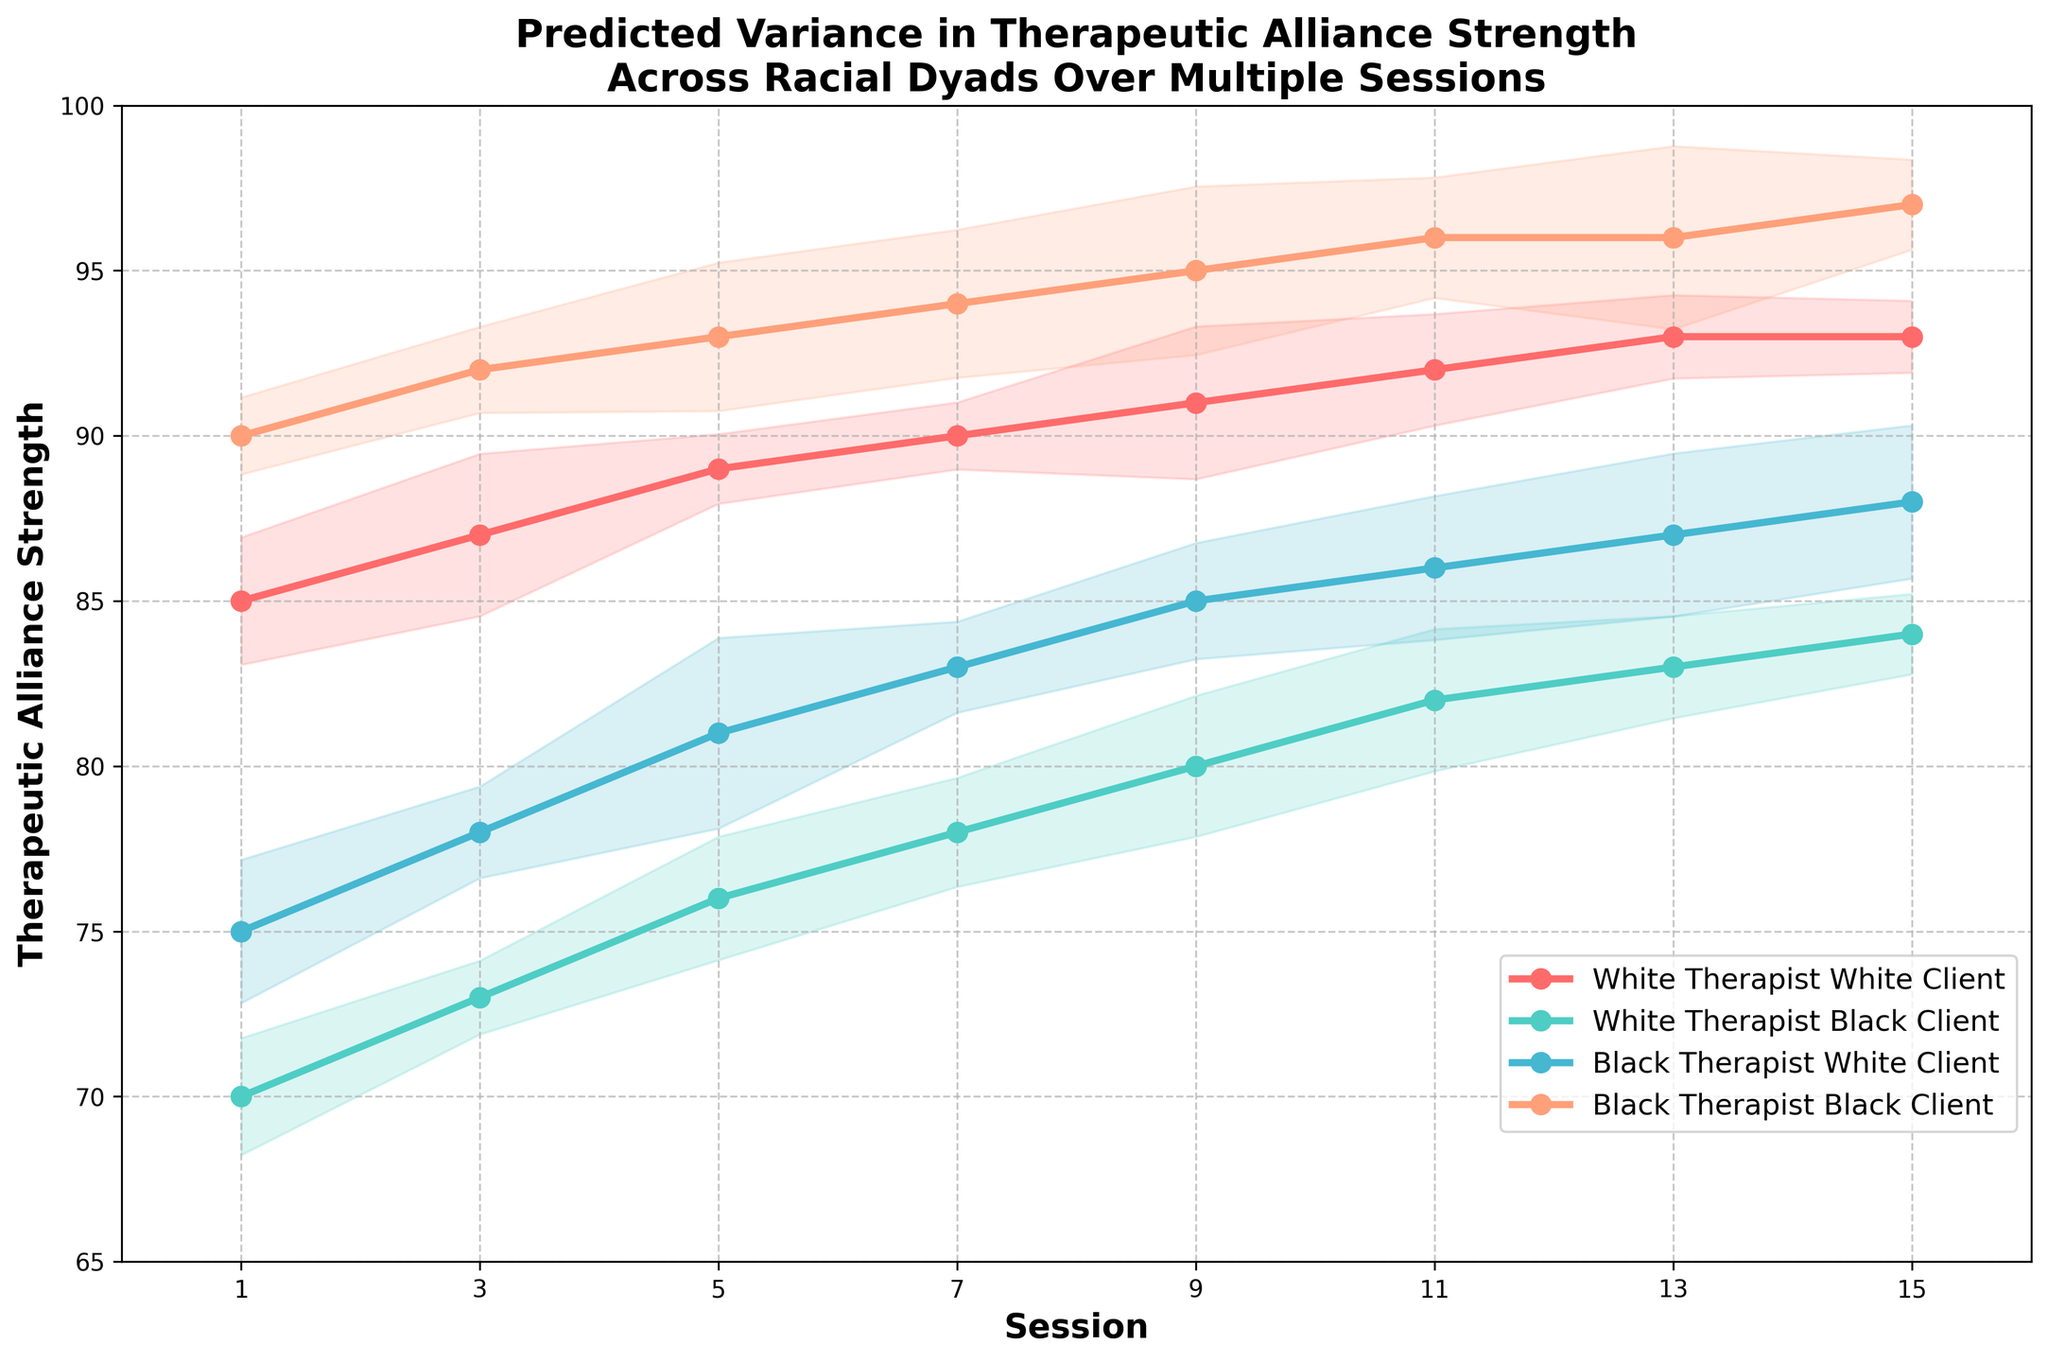What is the title of the figure? The title of the figure is located at the top and reads, "Predicted Variance in Therapeutic Alliance Strength Across Racial Dyads Over Multiple Sessions".
Answer: Predicted Variance in Therapeutic Alliance Strength Across Racial Dyads Over Multiple Sessions What is the therapeutic alliance strength for Black Therapist and Black Client dyad at session 9? Look at the data point for session 9 on the curve that corresponds to Black Therapist and Black Client, which is marked in a specific color, and check its value.
Answer: 95 Which dyad shows the highest therapeutic alliance strength in session 5? Compare the data points for all dyads at session 5 and identify the highest value. Black Therapist and Black Client have the highest value at 93.
Answer: Black Therapist and Black Client Between sessions 1 and 15, how does the therapeutic alliance strength change for White Therapist and Black Client? Identify the values for White Therapist and Black Client at sessions 1 and 15, and calculate the difference. At session 1, the value is 70, and at session 15, it's 84. The change is 84 - 70 = 14.
Answer: Increases by 14 What is the average therapeutic alliance strength of the Black Therapist and White Client dyad across all sessions? Sum the alliance strengths of Black Therapist and White Client over all sessions and then divide by the number of sessions. Values are 75, 78, 81, 83, 85, 86, 87, 88. The average is (75 + 78 + 81 + 83 + 85 + 86 + 87 + 88) / 8 = 82.875.
Answer: 82.875 Which dyad has the least variability in therapeutic alliance strength over the sessions? Examine the range of values for each dyad across all sessions. White Therapist and White Client varies from 85 to 93, White Therapist and Black Client from 70 to 84, Black Therapist and White Client from 75 to 88, and Black Therapist and Black Client from 90 to 97. The smallest range is for White Therapist and White Client, range = 93 - 85 = 8.
Answer: White Therapist and White Client At session 7, which two dyads have the closest therapeutic alliance strength values? Compare the values of all dyads at session 7 to find the pair with the smallest difference. White Therapist and Black Client has 78 and Black Therapist and White Client has 83, the difference is 83 - 78 = 5 which is the smallest.
Answer: White Therapist and Black Client and Black Therapist and White Client By how much does the therapeutic alliance strength for Black Therapist and Black Client increase from session 1 to session 11? Determine values for Black Therapist and Black Client at sessions 1 and 11, then find the change. The values are 90 and 96 respectively. The increase is 96 - 90 = 6.
Answer: 6 What range does the axis for sessions cover? The x-axis for sessions goes from 0 to 16, as indicated by the axis range.
Answer: 0 to 16 